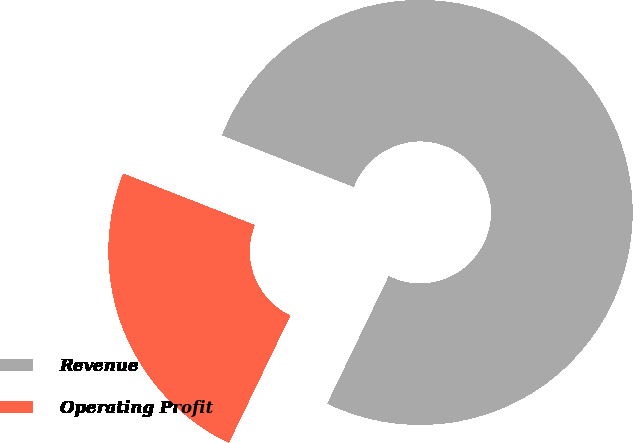<chart> <loc_0><loc_0><loc_500><loc_500><pie_chart><fcel>Revenue<fcel>Operating Profit<nl><fcel>76.22%<fcel>23.78%<nl></chart> 